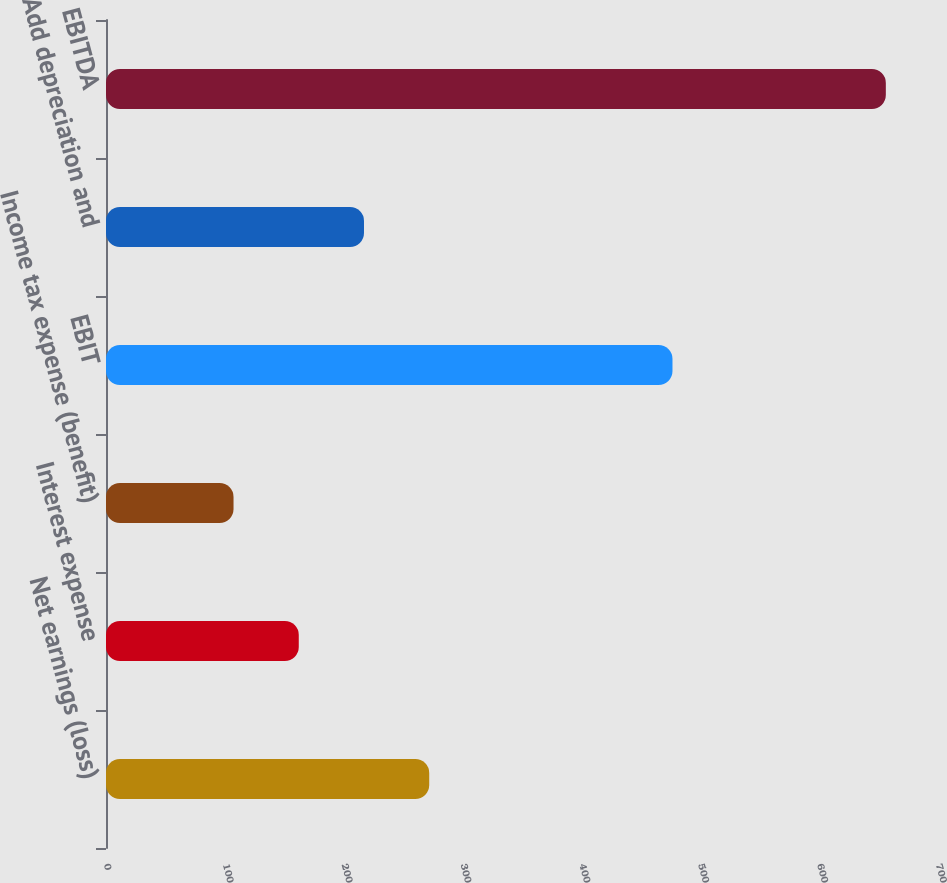<chart> <loc_0><loc_0><loc_500><loc_500><bar_chart><fcel>Net earnings (loss)<fcel>Interest expense<fcel>Income tax expense (benefit)<fcel>EBIT<fcel>Add depreciation and<fcel>EBITDA<nl><fcel>271.94<fcel>162.18<fcel>107.3<fcel>476.6<fcel>217.06<fcel>656.1<nl></chart> 